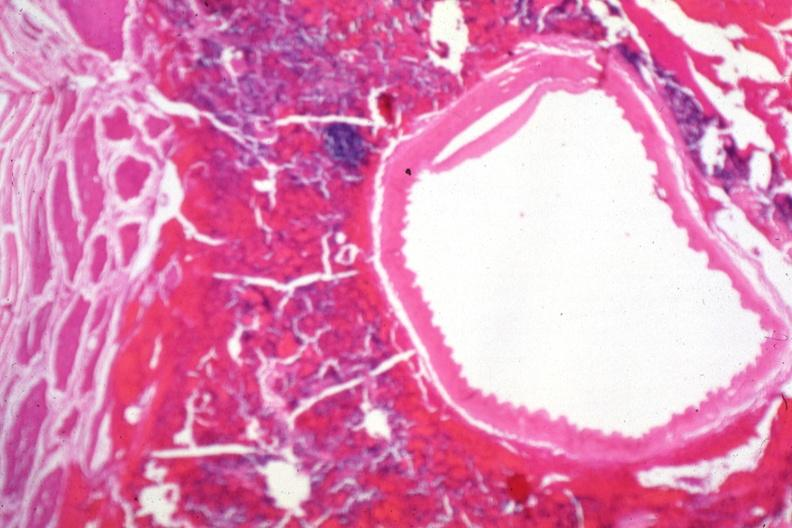where is this part in the figure?
Answer the question using a single word or phrase. Endocrine system 